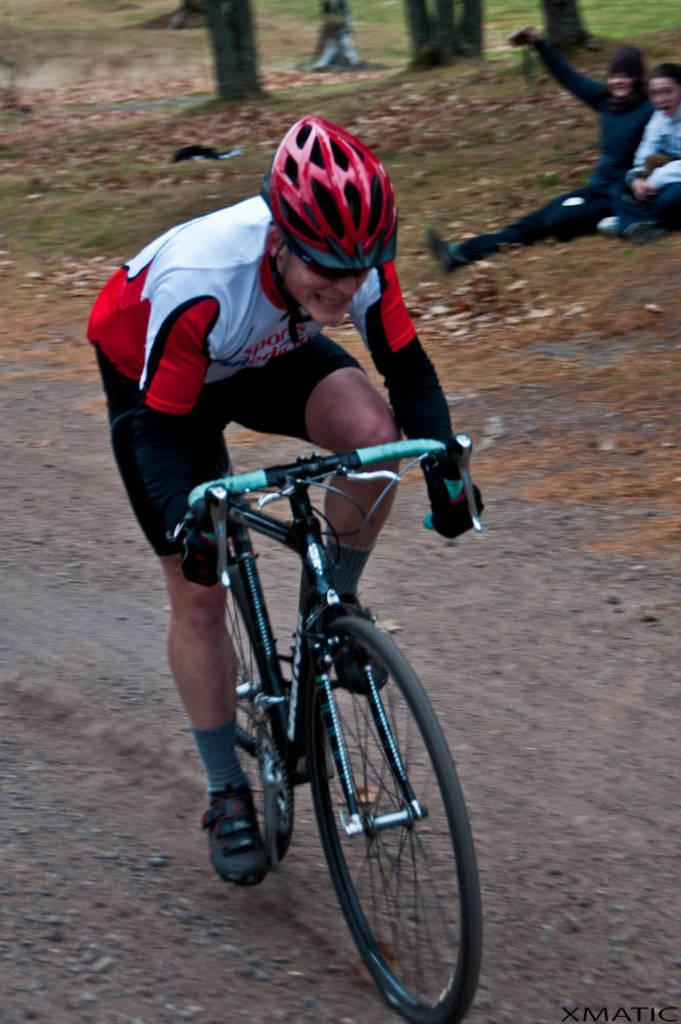Who is the main subject in the image? There is a man in the image. What is unique about the man in the image? The man is handicapped. What is the man doing in the image? The man is riding a bicycle. Can you describe the people in the background of the image? There are two persons sitting in the background of the image. What type of house is visible in the image? There is no house visible in the image. What color is the sky in the image? The provided facts do not mention the color of the sky, so we cannot determine the color of the sky from the image. 